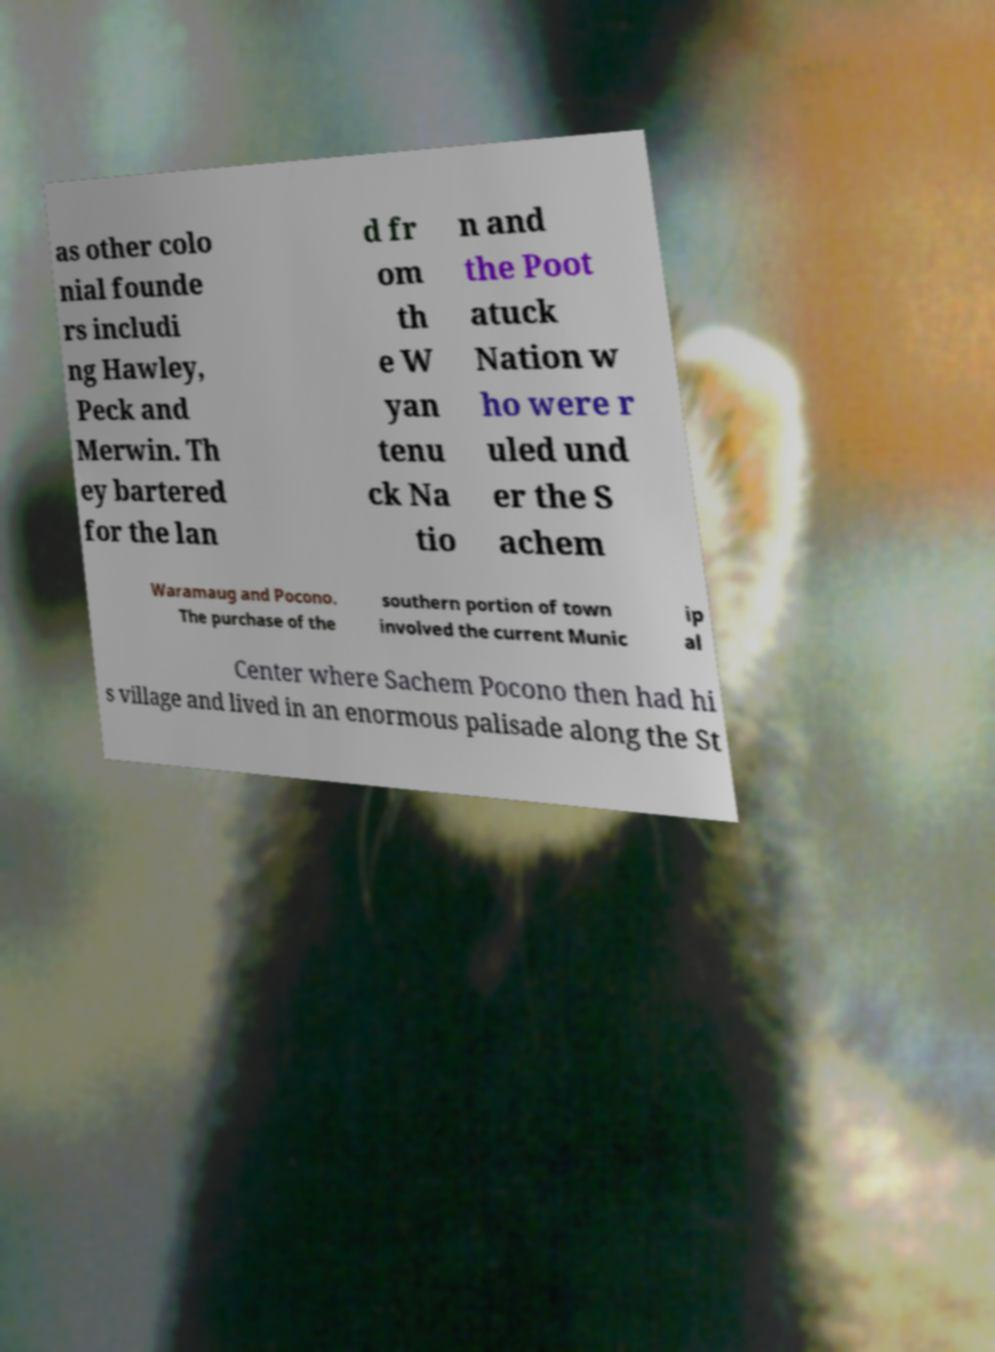Could you extract and type out the text from this image? as other colo nial founde rs includi ng Hawley, Peck and Merwin. Th ey bartered for the lan d fr om th e W yan tenu ck Na tio n and the Poot atuck Nation w ho were r uled und er the S achem Waramaug and Pocono. The purchase of the southern portion of town involved the current Munic ip al Center where Sachem Pocono then had hi s village and lived in an enormous palisade along the St 